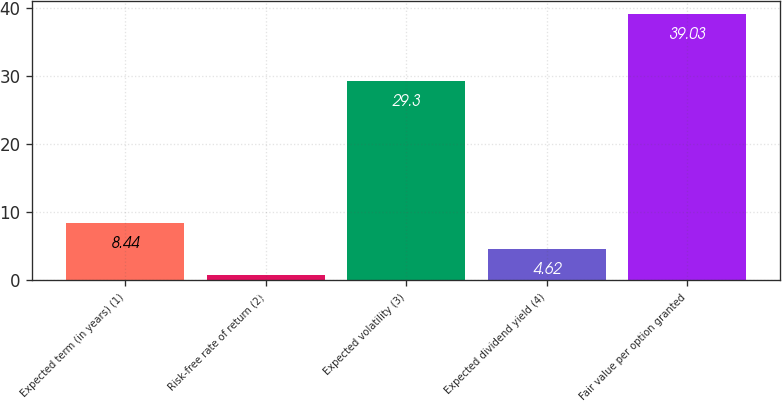Convert chart to OTSL. <chart><loc_0><loc_0><loc_500><loc_500><bar_chart><fcel>Expected term (in years) (1)<fcel>Risk-free rate of return (2)<fcel>Expected volatility (3)<fcel>Expected dividend yield (4)<fcel>Fair value per option granted<nl><fcel>8.44<fcel>0.8<fcel>29.3<fcel>4.62<fcel>39.03<nl></chart> 